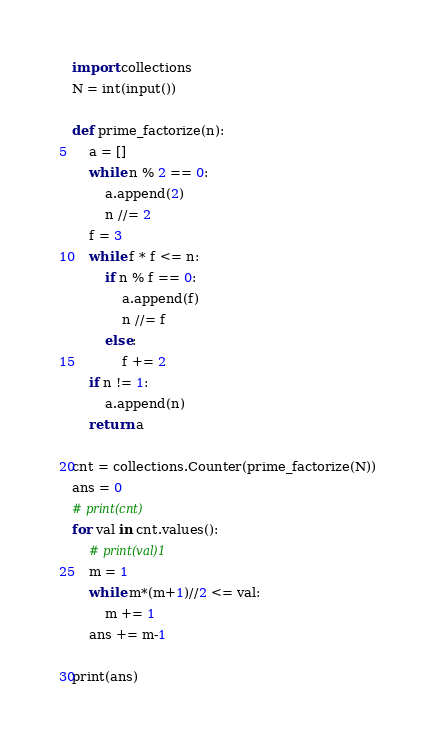Convert code to text. <code><loc_0><loc_0><loc_500><loc_500><_Python_>import collections
N = int(input())

def prime_factorize(n):
    a = []
    while n % 2 == 0:
        a.append(2)
        n //= 2
    f = 3
    while f * f <= n:
        if n % f == 0:
            a.append(f)
            n //= f
        else:
            f += 2
    if n != 1:
        a.append(n)
    return a

cnt = collections.Counter(prime_factorize(N))
ans = 0
# print(cnt)
for val in cnt.values():
    # print(val)1
    m = 1
    while m*(m+1)//2 <= val:
        m += 1
    ans += m-1

print(ans)</code> 